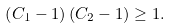<formula> <loc_0><loc_0><loc_500><loc_500>\left ( C _ { 1 } - 1 \right ) \left ( C _ { 2 } - 1 \right ) \geq 1 .</formula> 